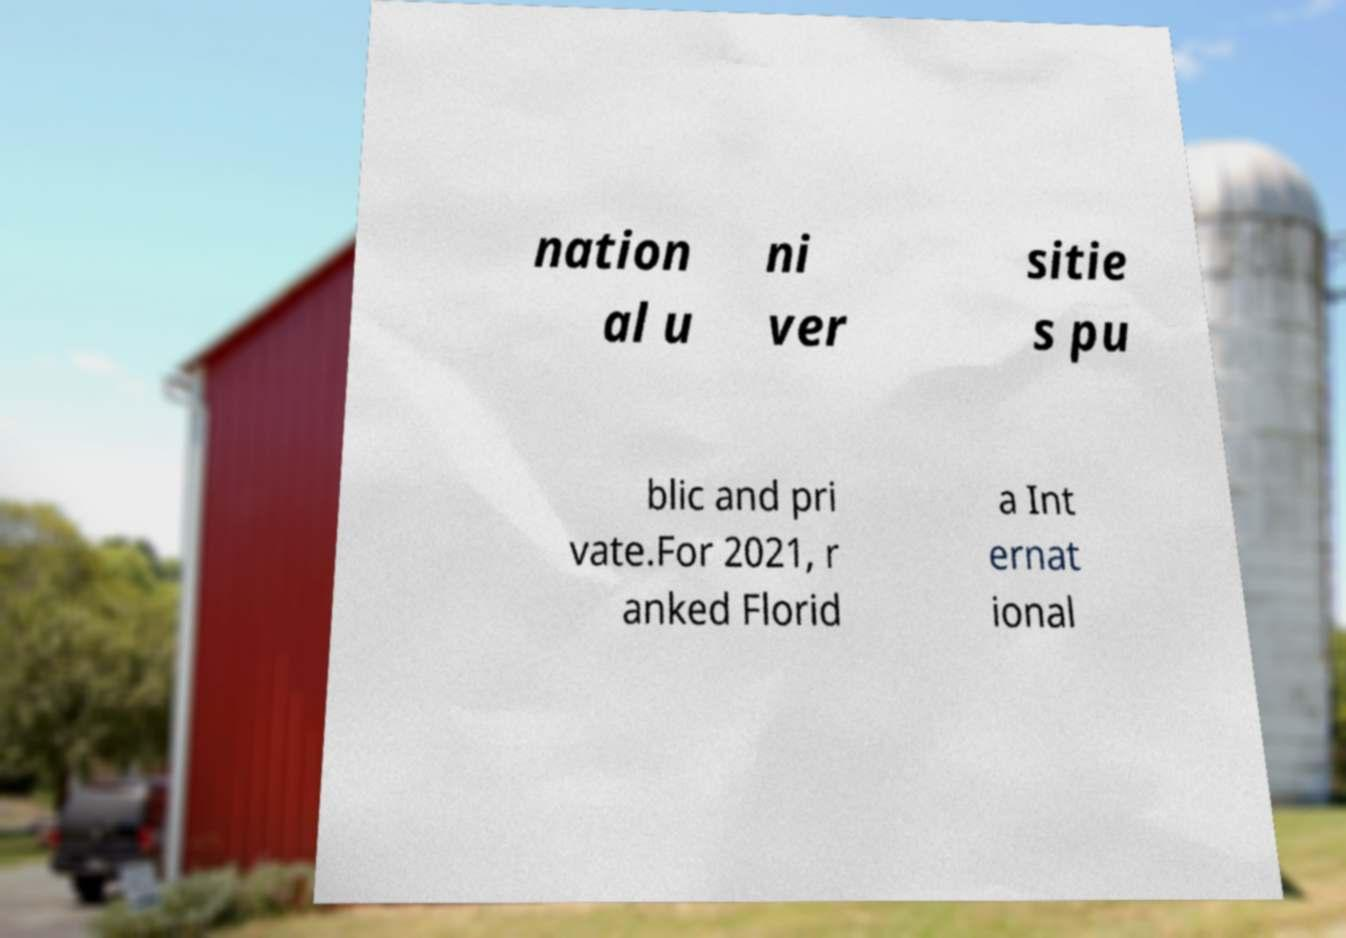What messages or text are displayed in this image? I need them in a readable, typed format. nation al u ni ver sitie s pu blic and pri vate.For 2021, r anked Florid a Int ernat ional 